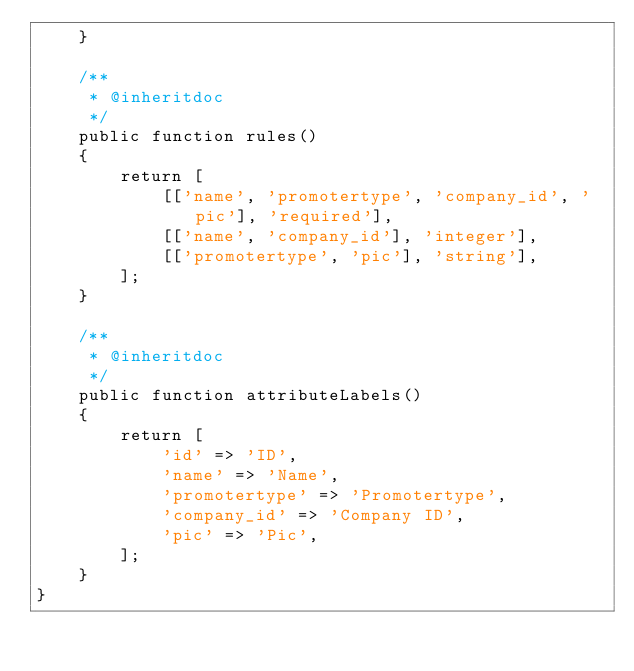<code> <loc_0><loc_0><loc_500><loc_500><_PHP_>    }

    /**
     * @inheritdoc
     */
    public function rules()
    {
        return [
            [['name', 'promotertype', 'company_id', 'pic'], 'required'],
            [['name', 'company_id'], 'integer'],
            [['promotertype', 'pic'], 'string'],
        ];
    }

    /**
     * @inheritdoc
     */
    public function attributeLabels()
    {
        return [
            'id' => 'ID',
            'name' => 'Name',
            'promotertype' => 'Promotertype',
            'company_id' => 'Company ID',
            'pic' => 'Pic',
        ];
    }
}
</code> 